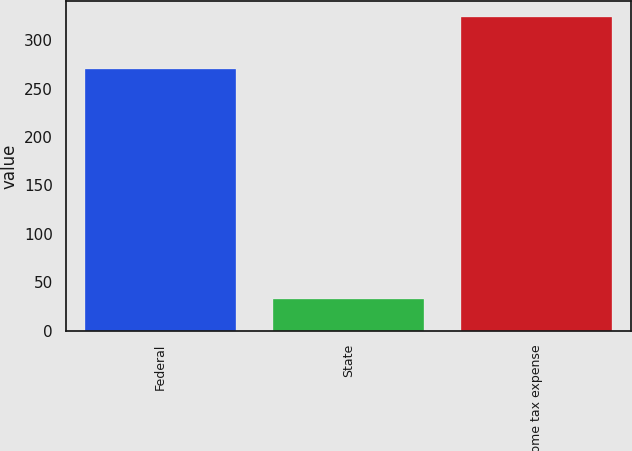<chart> <loc_0><loc_0><loc_500><loc_500><bar_chart><fcel>Federal<fcel>State<fcel>Income tax expense<nl><fcel>270.6<fcel>33.2<fcel>324.3<nl></chart> 